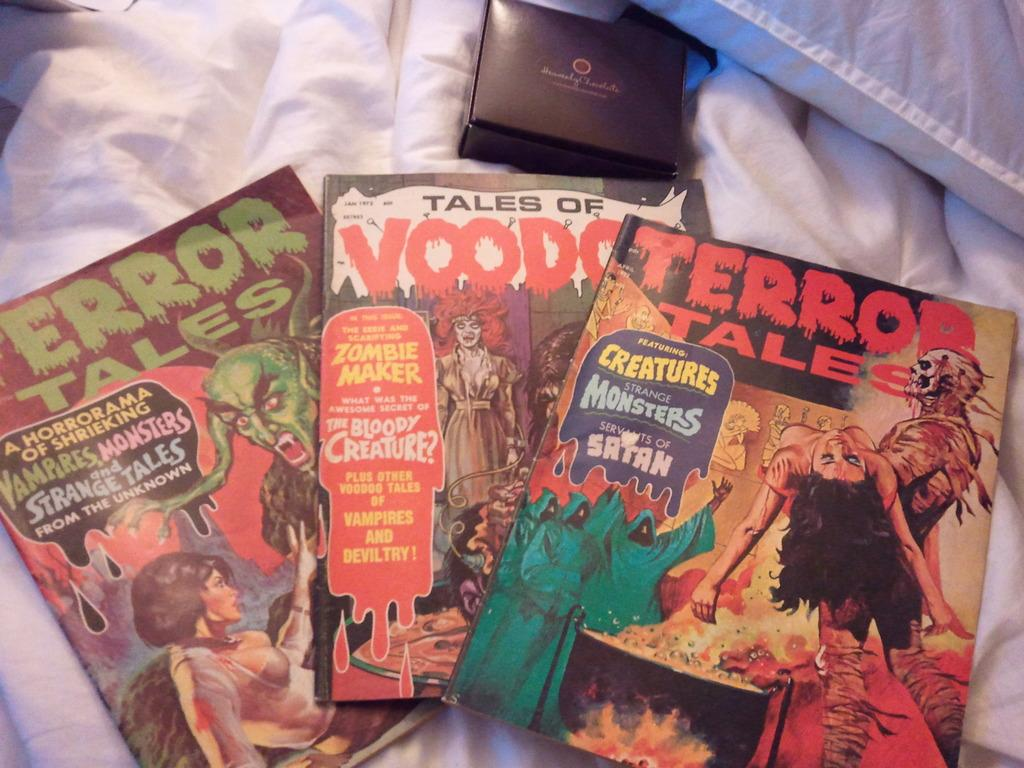<image>
Relay a brief, clear account of the picture shown. Comic books of Terror tales laying on the bed with a black box above with the words Heavenly Chocolate on it. 